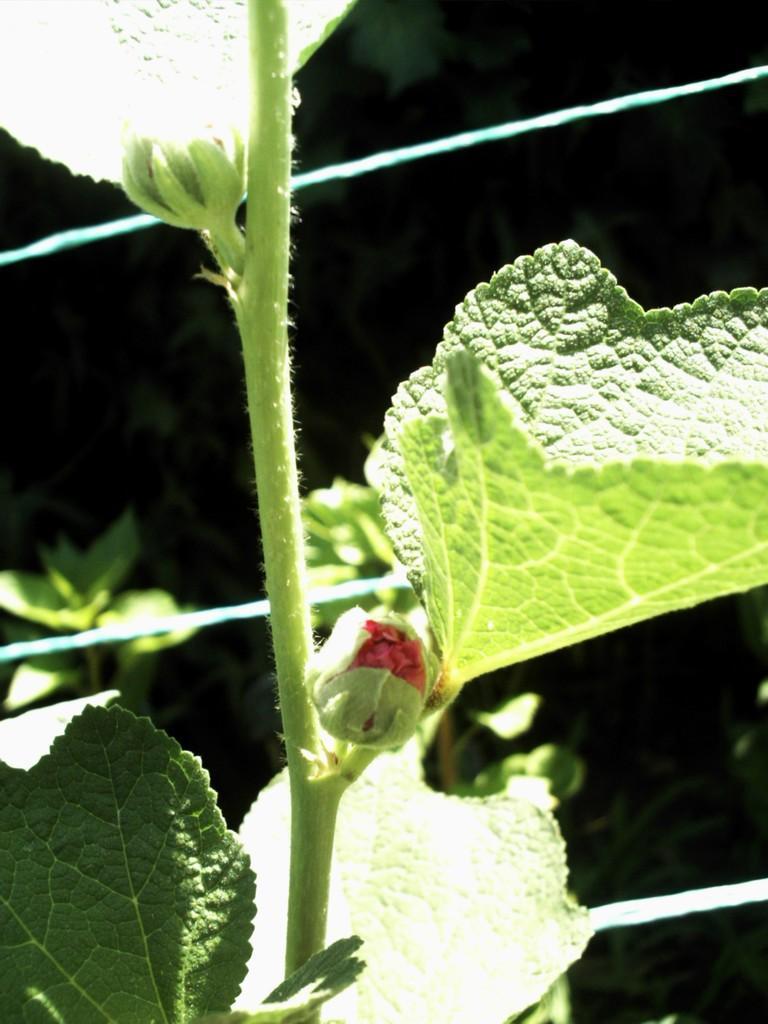Could you give a brief overview of what you see in this image? In this picture we can observe flower buds. There are leaves. We can observe a plant hire. In the background it is completely dark. We can observe some wires. 